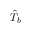Convert formula to latex. <formula><loc_0><loc_0><loc_500><loc_500>\hat { T } _ { b }</formula> 